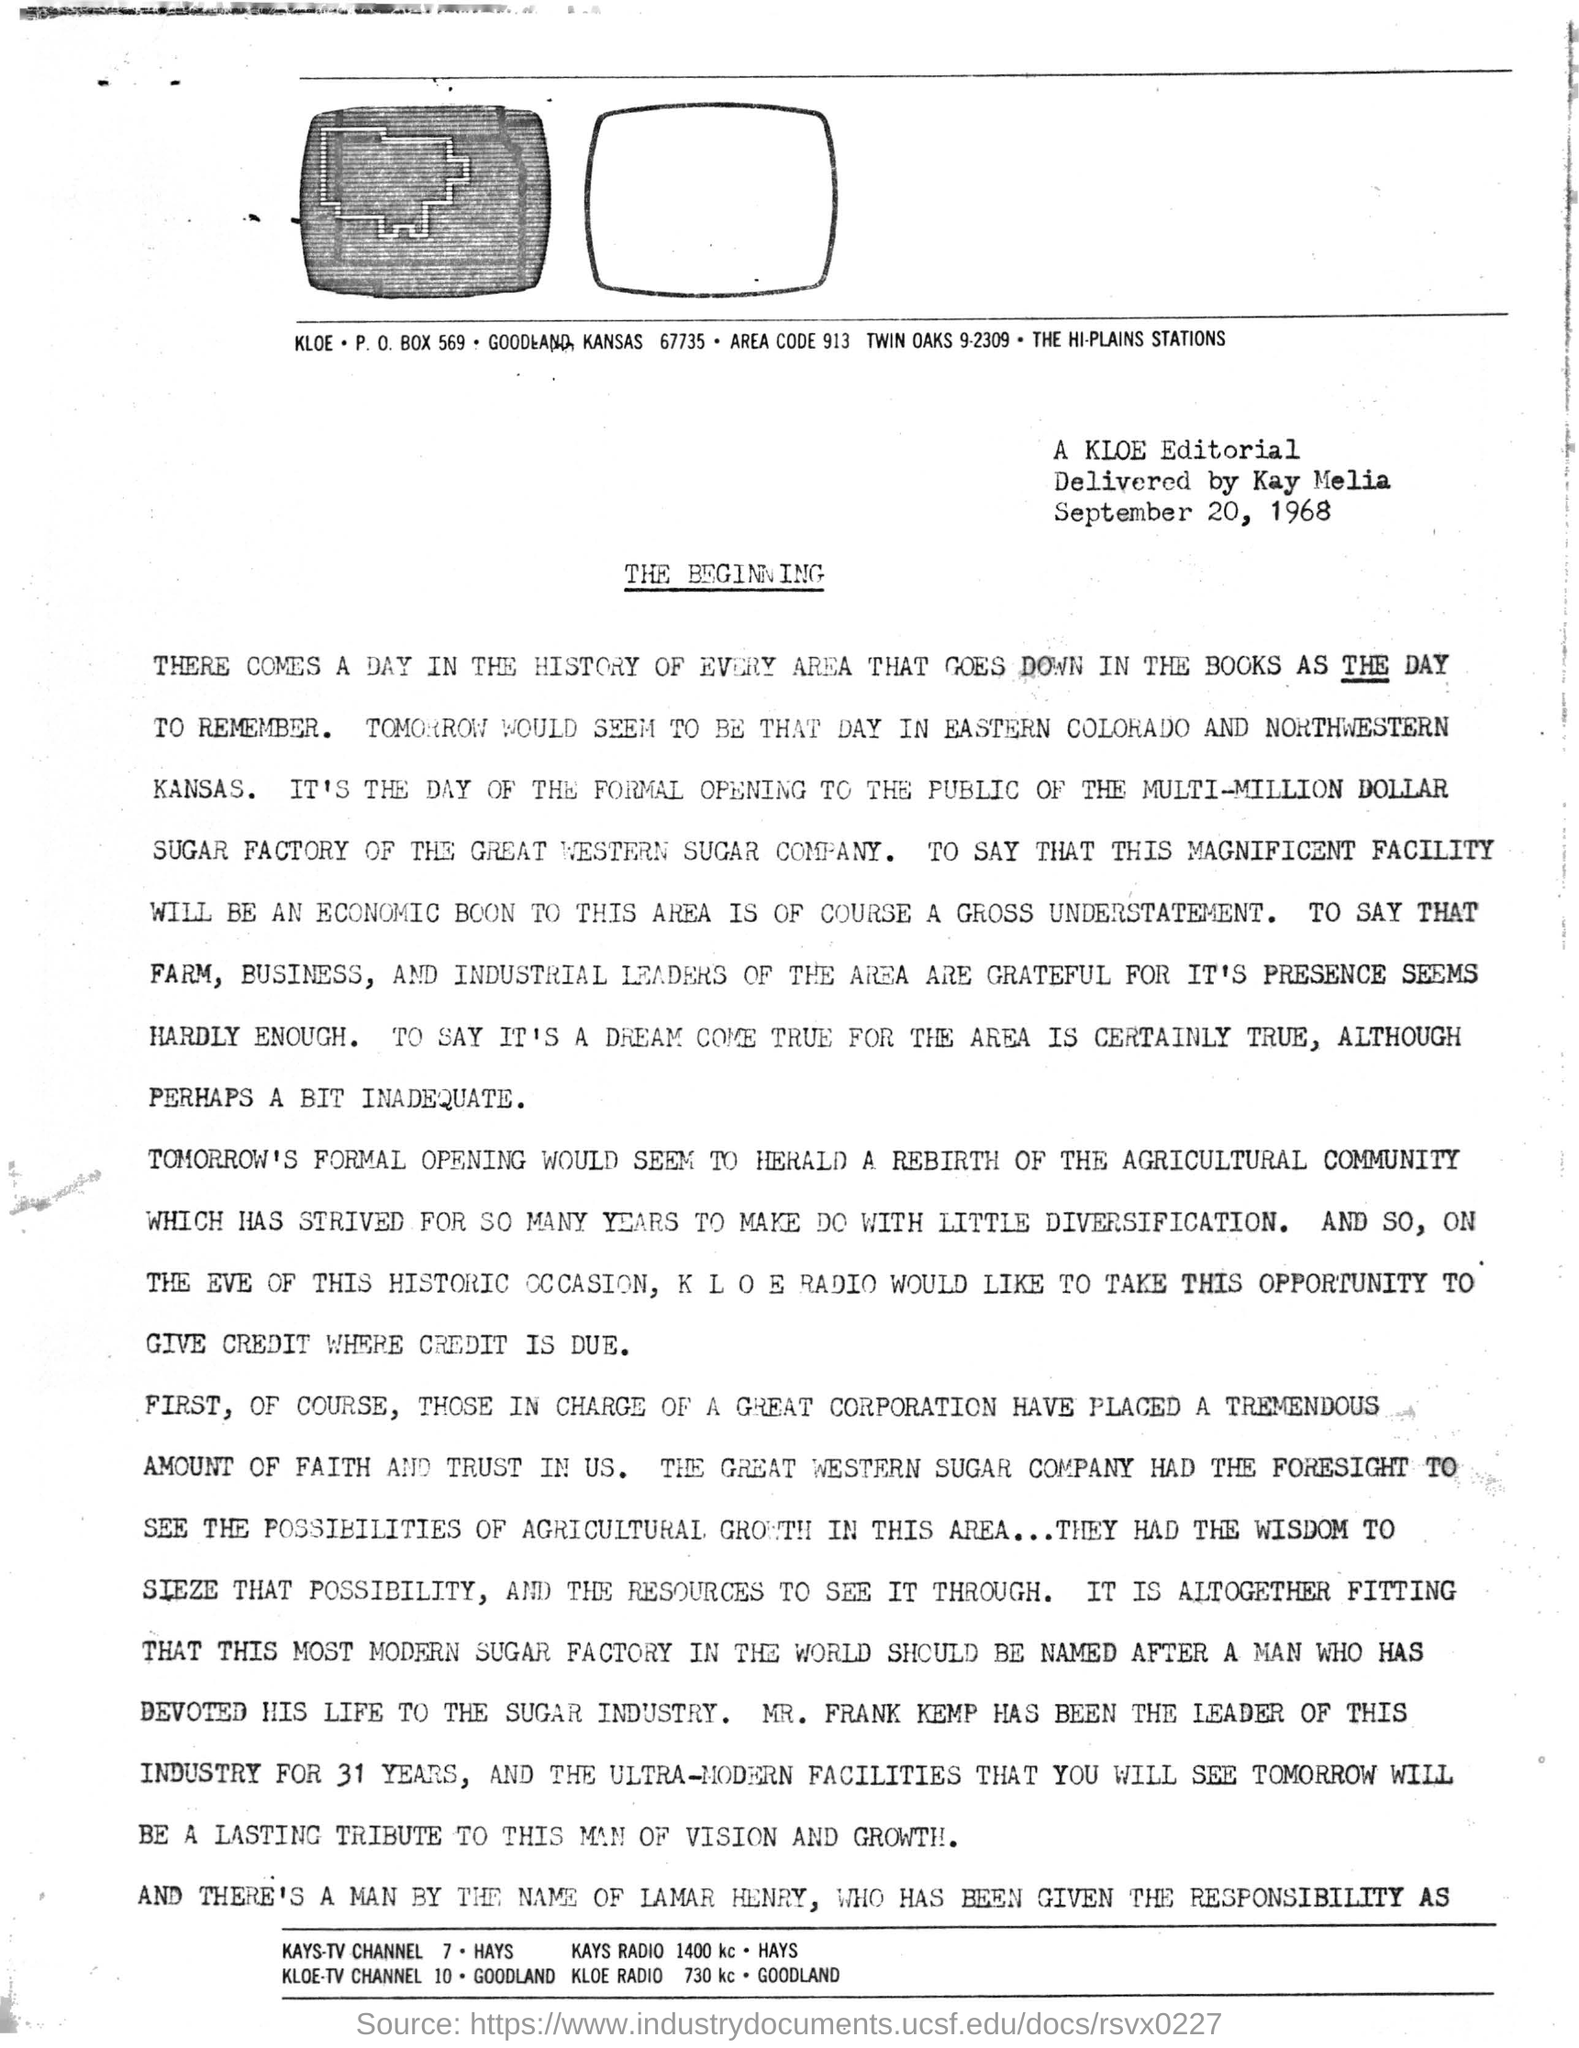What is the P.O. Box number written under the first image?
Give a very brief answer. 569. What is the 'AREA CODE' written under the image?
Give a very brief answer. 913. Who delivered the editorial?
Ensure brevity in your answer.  Kay Melia. Which is the date mentioned related to Editorial?
Provide a short and direct response. September 20, 1968. 